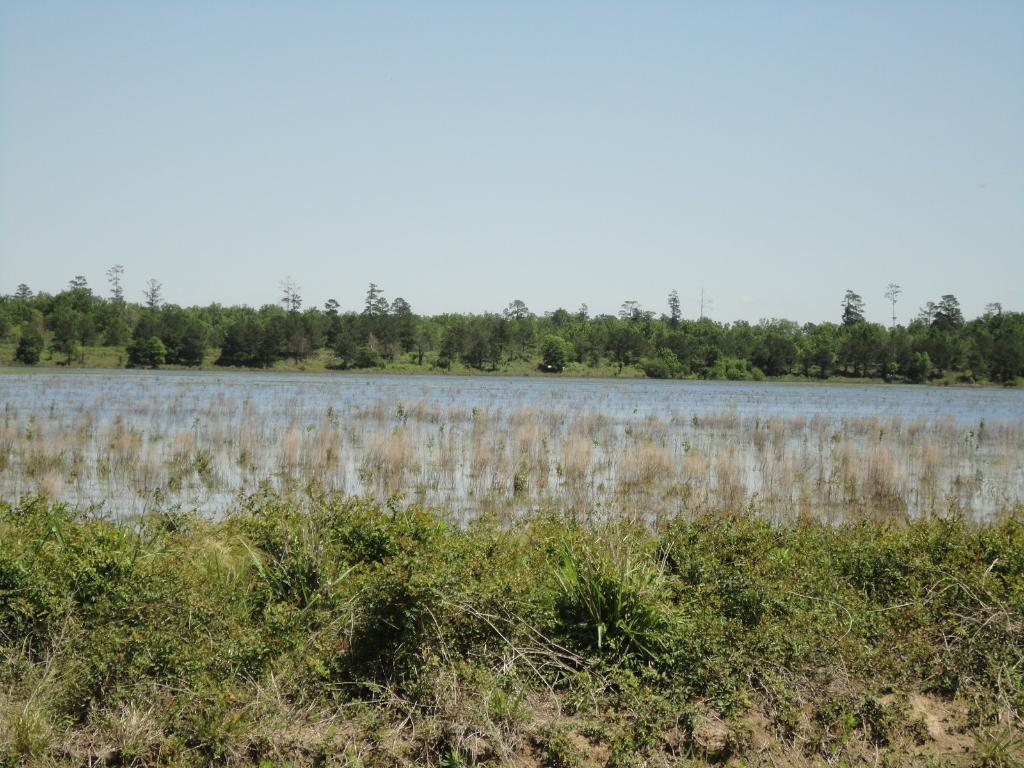What type of living organisms can be seen in the image? Plants and trees are visible in the image. What is the primary element in which the plants are situated? There is water visible in the image, and the plants are situated in it. What type of vegetation is present in the image? Trees are present in the image. What type of coil can be seen in the image? There is no coil present in the image. What type of button is being used to control the plants in the image? There is no button present in the image, and plants do not require control. 